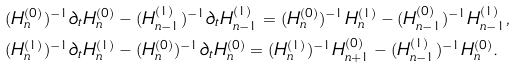Convert formula to latex. <formula><loc_0><loc_0><loc_500><loc_500>& ( H _ { n } ^ { ( 0 ) } ) ^ { - 1 } \partial _ { t } H _ { n } ^ { ( 0 ) } - ( H _ { n - 1 } ^ { ( 1 ) } ) ^ { - 1 } \partial _ { t } H _ { n - 1 } ^ { ( 1 ) } = ( H _ { n } ^ { ( 0 ) } ) ^ { - 1 } H _ { n } ^ { ( 1 ) } - ( H _ { n - 1 } ^ { ( 0 ) } ) ^ { - 1 } H _ { n - 1 } ^ { ( 1 ) } , \\ & ( H _ { n } ^ { ( 1 ) } ) ^ { - 1 } \partial _ { t } H _ { n } ^ { ( 1 ) } - ( H _ { n } ^ { ( 0 ) } ) ^ { - 1 } \partial _ { t } H _ { n } ^ { ( 0 ) } = ( H _ { n } ^ { ( 1 ) } ) ^ { - 1 } H _ { n + 1 } ^ { ( 0 ) } - ( H _ { n - 1 } ^ { ( 1 ) } ) ^ { - 1 } H _ { n } ^ { ( 0 ) } .</formula> 